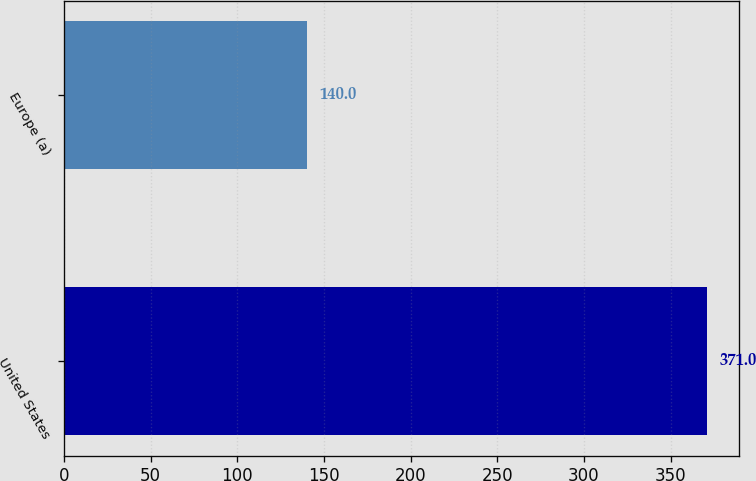Convert chart. <chart><loc_0><loc_0><loc_500><loc_500><bar_chart><fcel>United States<fcel>Europe (a)<nl><fcel>371<fcel>140<nl></chart> 